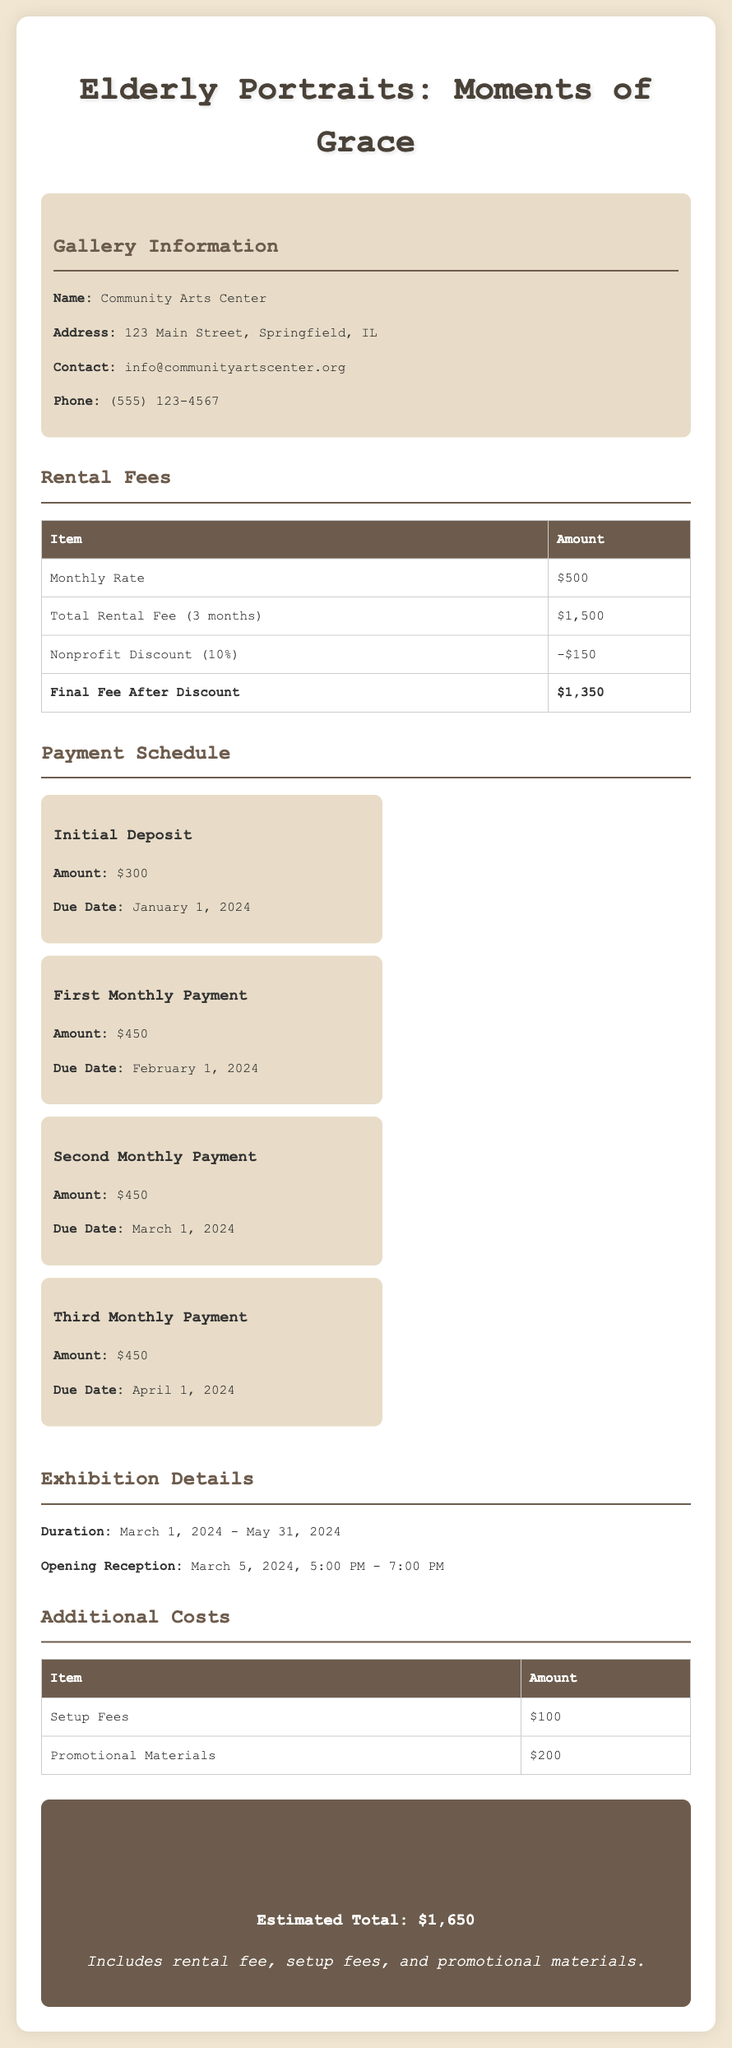what is the name of the gallery? The name of the gallery is listed in the gallery information section, which is Community Arts Center.
Answer: Community Arts Center what is the initial deposit amount? The initial deposit amount is given under the payment schedule section, which is $300.
Answer: $300 how much is the monthly rental fee? The monthly rental fee is presented in the rental fees section of the document, which is $500.
Answer: $500 when is the due date for the first monthly payment? The due date for the first monthly payment can be found in the payment schedule section, which is February 1, 2024.
Answer: February 1, 2024 what is the total rental fee before the discount? The total rental fee for three months, prior to any discounts, is specified as $1,500 in the rental fees table.
Answer: $1,500 how much is the nonprofit discount? The nonprofit discount is indicated in the rental fees section as 10% of the total rental fee, which amounts to $150.
Answer: $150 what is the duration of the exhibition? The exhibition duration is clarified in the exhibition details section as March 1, 2024 - May 31, 2024.
Answer: March 1, 2024 - May 31, 2024 what is the estimated total budget? The estimated total budget is summarized at the end of the document, amounting to $1,650.
Answer: $1,650 what is the cost for setup fees? The cost for setup fees is detailed in the additional costs section, which is $100.
Answer: $100 